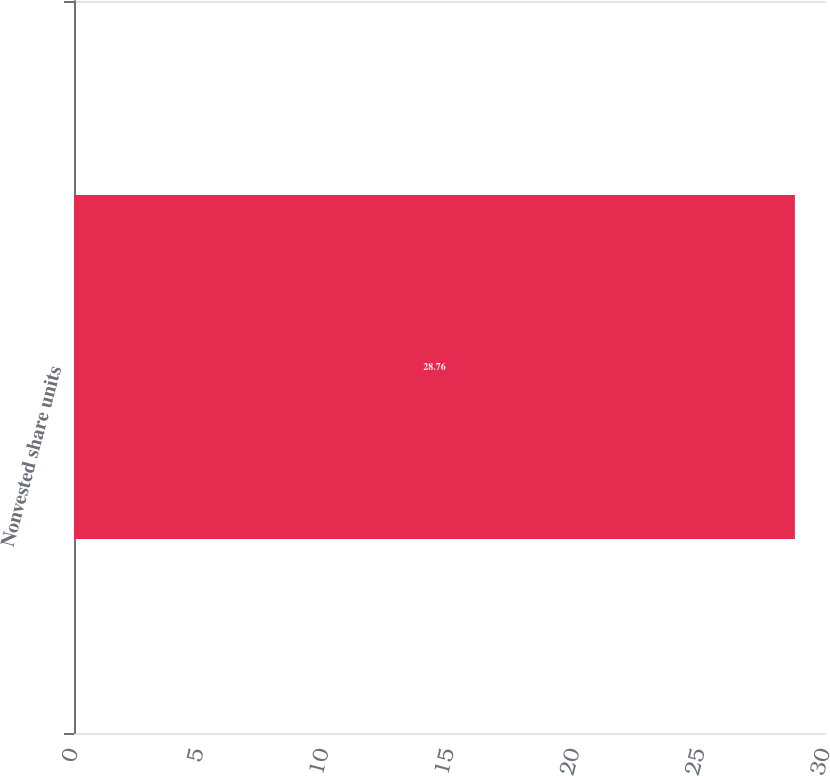<chart> <loc_0><loc_0><loc_500><loc_500><bar_chart><fcel>Nonvested share units<nl><fcel>28.76<nl></chart> 